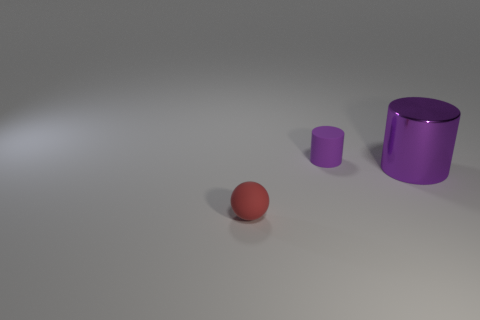Is there any other thing that is the same size as the purple metal cylinder?
Your answer should be very brief. No. What is the color of the other tiny object that is the same material as the red object?
Provide a short and direct response. Purple. Are there any balls of the same size as the red rubber object?
Make the answer very short. No. There is another purple thing that is the same shape as the large purple object; what is it made of?
Your response must be concise. Rubber. There is a purple matte object that is the same size as the ball; what shape is it?
Keep it short and to the point. Cylinder. Are there any cyan matte things of the same shape as the tiny purple rubber object?
Your response must be concise. No. There is a small matte thing that is in front of the tiny object that is behind the metal thing; what shape is it?
Your answer should be very brief. Sphere. What is the shape of the tiny red thing?
Keep it short and to the point. Sphere. What is the material of the tiny thing behind the small rubber ball in front of the small rubber object right of the rubber sphere?
Ensure brevity in your answer.  Rubber. What number of other objects are there of the same material as the big cylinder?
Keep it short and to the point. 0. 